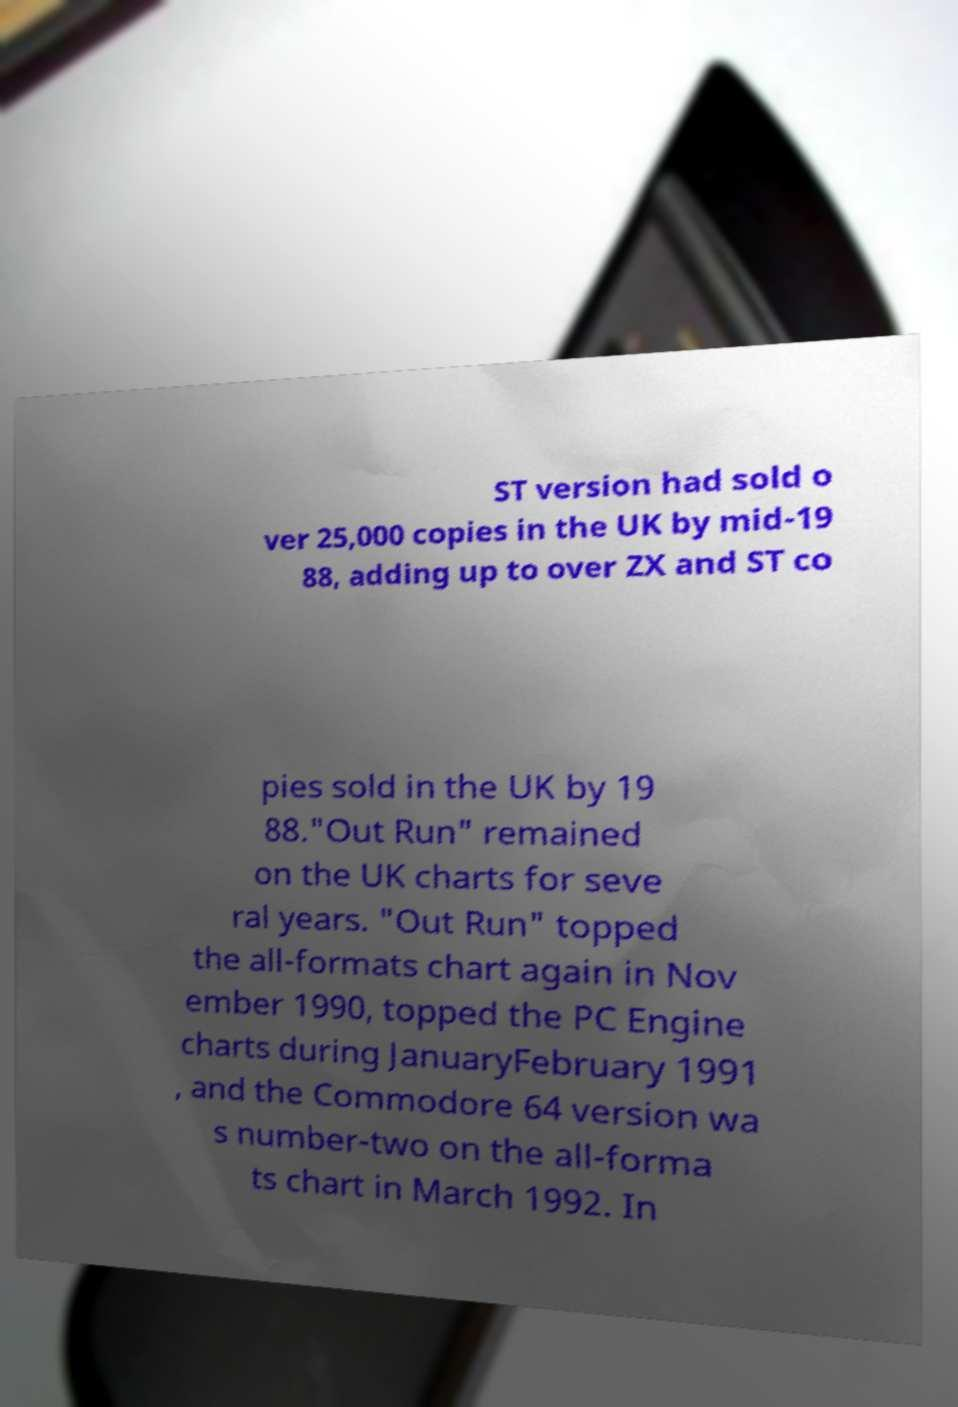Please read and relay the text visible in this image. What does it say? ST version had sold o ver 25,000 copies in the UK by mid-19 88, adding up to over ZX and ST co pies sold in the UK by 19 88."Out Run" remained on the UK charts for seve ral years. "Out Run" topped the all-formats chart again in Nov ember 1990, topped the PC Engine charts during JanuaryFebruary 1991 , and the Commodore 64 version wa s number-two on the all-forma ts chart in March 1992. In 